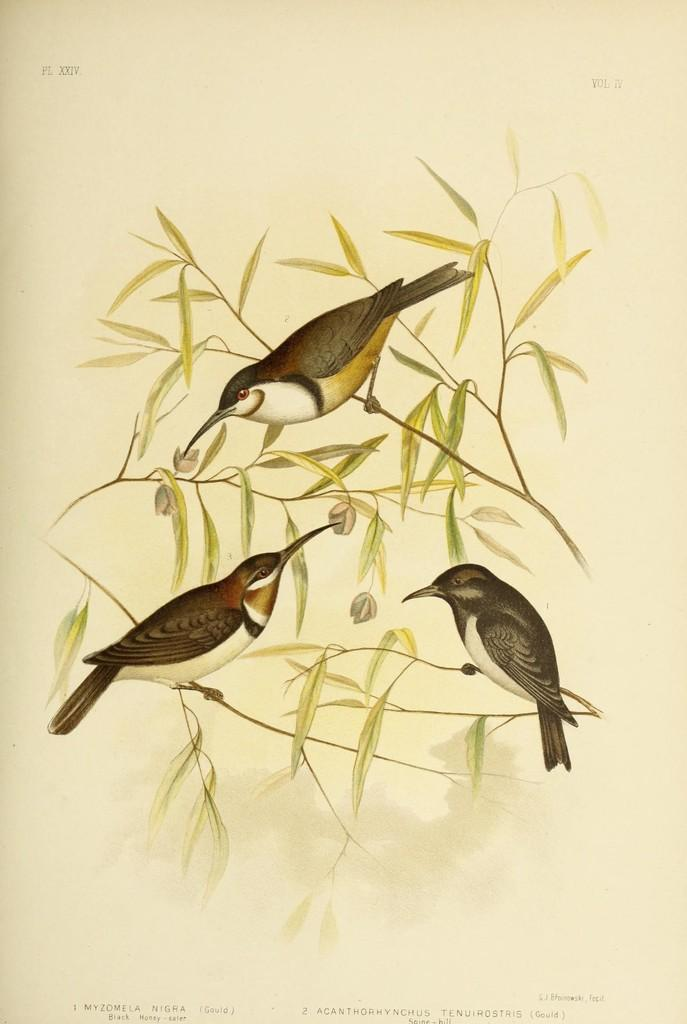What is the main subject of the image? The image contains a painting. What is being depicted in the painting? The painting depicts birds. Where are the birds located in the painting? The birds are on branches. What can be seen on the branches in the painting? The branches have leaves. How much money is being exchanged between the birds in the painting? There is no exchange of money depicted in the painting; it features birds on branches with leaves. What type of degree does the artist who created the painting have? The degree of the artist who created the painting is not mentioned or visible in the image. 